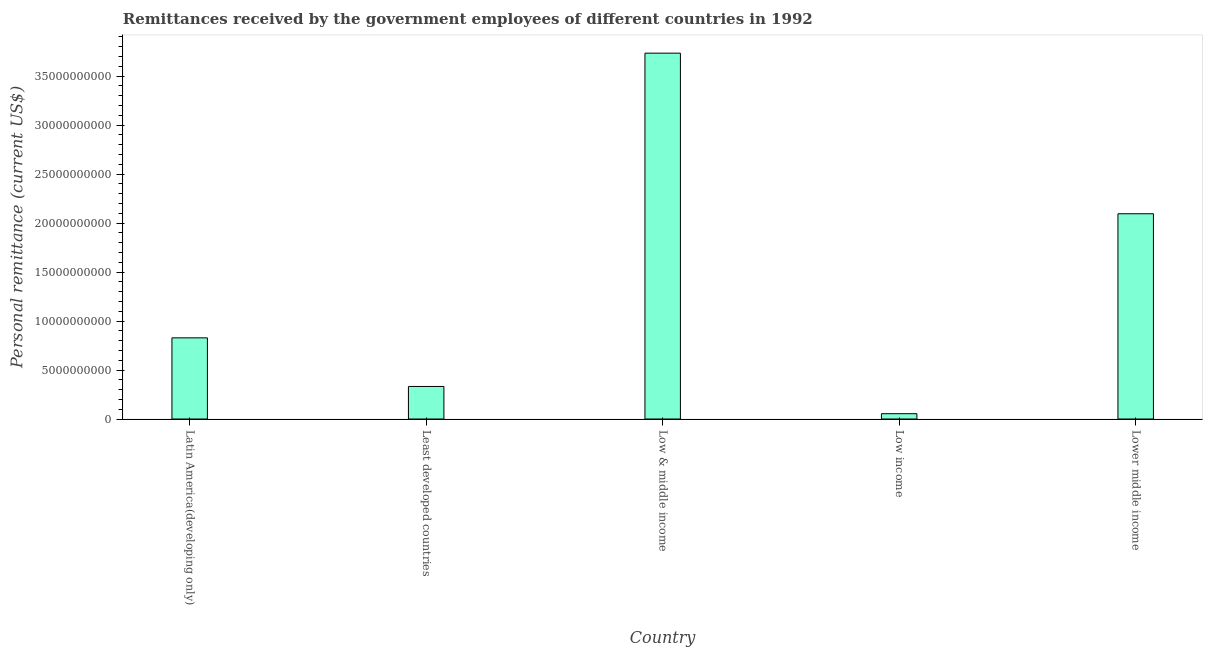Does the graph contain any zero values?
Provide a succinct answer. No. Does the graph contain grids?
Your answer should be very brief. No. What is the title of the graph?
Provide a short and direct response. Remittances received by the government employees of different countries in 1992. What is the label or title of the X-axis?
Ensure brevity in your answer.  Country. What is the label or title of the Y-axis?
Provide a succinct answer. Personal remittance (current US$). What is the personal remittances in Lower middle income?
Your response must be concise. 2.09e+1. Across all countries, what is the maximum personal remittances?
Make the answer very short. 3.73e+1. Across all countries, what is the minimum personal remittances?
Offer a very short reply. 5.43e+08. In which country was the personal remittances maximum?
Give a very brief answer. Low & middle income. What is the sum of the personal remittances?
Make the answer very short. 7.04e+1. What is the difference between the personal remittances in Latin America(developing only) and Least developed countries?
Offer a terse response. 4.96e+09. What is the average personal remittances per country?
Provide a short and direct response. 1.41e+1. What is the median personal remittances?
Provide a succinct answer. 8.28e+09. In how many countries, is the personal remittances greater than 30000000000 US$?
Provide a short and direct response. 1. What is the ratio of the personal remittances in Least developed countries to that in Low income?
Give a very brief answer. 6.12. What is the difference between the highest and the second highest personal remittances?
Ensure brevity in your answer.  1.64e+1. What is the difference between the highest and the lowest personal remittances?
Make the answer very short. 3.68e+1. In how many countries, is the personal remittances greater than the average personal remittances taken over all countries?
Make the answer very short. 2. Are all the bars in the graph horizontal?
Provide a short and direct response. No. What is the difference between two consecutive major ticks on the Y-axis?
Give a very brief answer. 5.00e+09. Are the values on the major ticks of Y-axis written in scientific E-notation?
Provide a short and direct response. No. What is the Personal remittance (current US$) of Latin America(developing only)?
Provide a succinct answer. 8.28e+09. What is the Personal remittance (current US$) in Least developed countries?
Give a very brief answer. 3.32e+09. What is the Personal remittance (current US$) of Low & middle income?
Provide a succinct answer. 3.73e+1. What is the Personal remittance (current US$) of Low income?
Give a very brief answer. 5.43e+08. What is the Personal remittance (current US$) of Lower middle income?
Keep it short and to the point. 2.09e+1. What is the difference between the Personal remittance (current US$) in Latin America(developing only) and Least developed countries?
Provide a succinct answer. 4.96e+09. What is the difference between the Personal remittance (current US$) in Latin America(developing only) and Low & middle income?
Your answer should be compact. -2.91e+1. What is the difference between the Personal remittance (current US$) in Latin America(developing only) and Low income?
Make the answer very short. 7.74e+09. What is the difference between the Personal remittance (current US$) in Latin America(developing only) and Lower middle income?
Provide a short and direct response. -1.27e+1. What is the difference between the Personal remittance (current US$) in Least developed countries and Low & middle income?
Offer a terse response. -3.40e+1. What is the difference between the Personal remittance (current US$) in Least developed countries and Low income?
Offer a very short reply. 2.78e+09. What is the difference between the Personal remittance (current US$) in Least developed countries and Lower middle income?
Give a very brief answer. -1.76e+1. What is the difference between the Personal remittance (current US$) in Low & middle income and Low income?
Provide a short and direct response. 3.68e+1. What is the difference between the Personal remittance (current US$) in Low & middle income and Lower middle income?
Offer a terse response. 1.64e+1. What is the difference between the Personal remittance (current US$) in Low income and Lower middle income?
Keep it short and to the point. -2.04e+1. What is the ratio of the Personal remittance (current US$) in Latin America(developing only) to that in Least developed countries?
Keep it short and to the point. 2.49. What is the ratio of the Personal remittance (current US$) in Latin America(developing only) to that in Low & middle income?
Offer a terse response. 0.22. What is the ratio of the Personal remittance (current US$) in Latin America(developing only) to that in Low income?
Make the answer very short. 15.26. What is the ratio of the Personal remittance (current US$) in Latin America(developing only) to that in Lower middle income?
Your response must be concise. 0.4. What is the ratio of the Personal remittance (current US$) in Least developed countries to that in Low & middle income?
Your response must be concise. 0.09. What is the ratio of the Personal remittance (current US$) in Least developed countries to that in Low income?
Offer a very short reply. 6.12. What is the ratio of the Personal remittance (current US$) in Least developed countries to that in Lower middle income?
Provide a succinct answer. 0.16. What is the ratio of the Personal remittance (current US$) in Low & middle income to that in Low income?
Your answer should be very brief. 68.79. What is the ratio of the Personal remittance (current US$) in Low & middle income to that in Lower middle income?
Your response must be concise. 1.78. What is the ratio of the Personal remittance (current US$) in Low income to that in Lower middle income?
Keep it short and to the point. 0.03. 